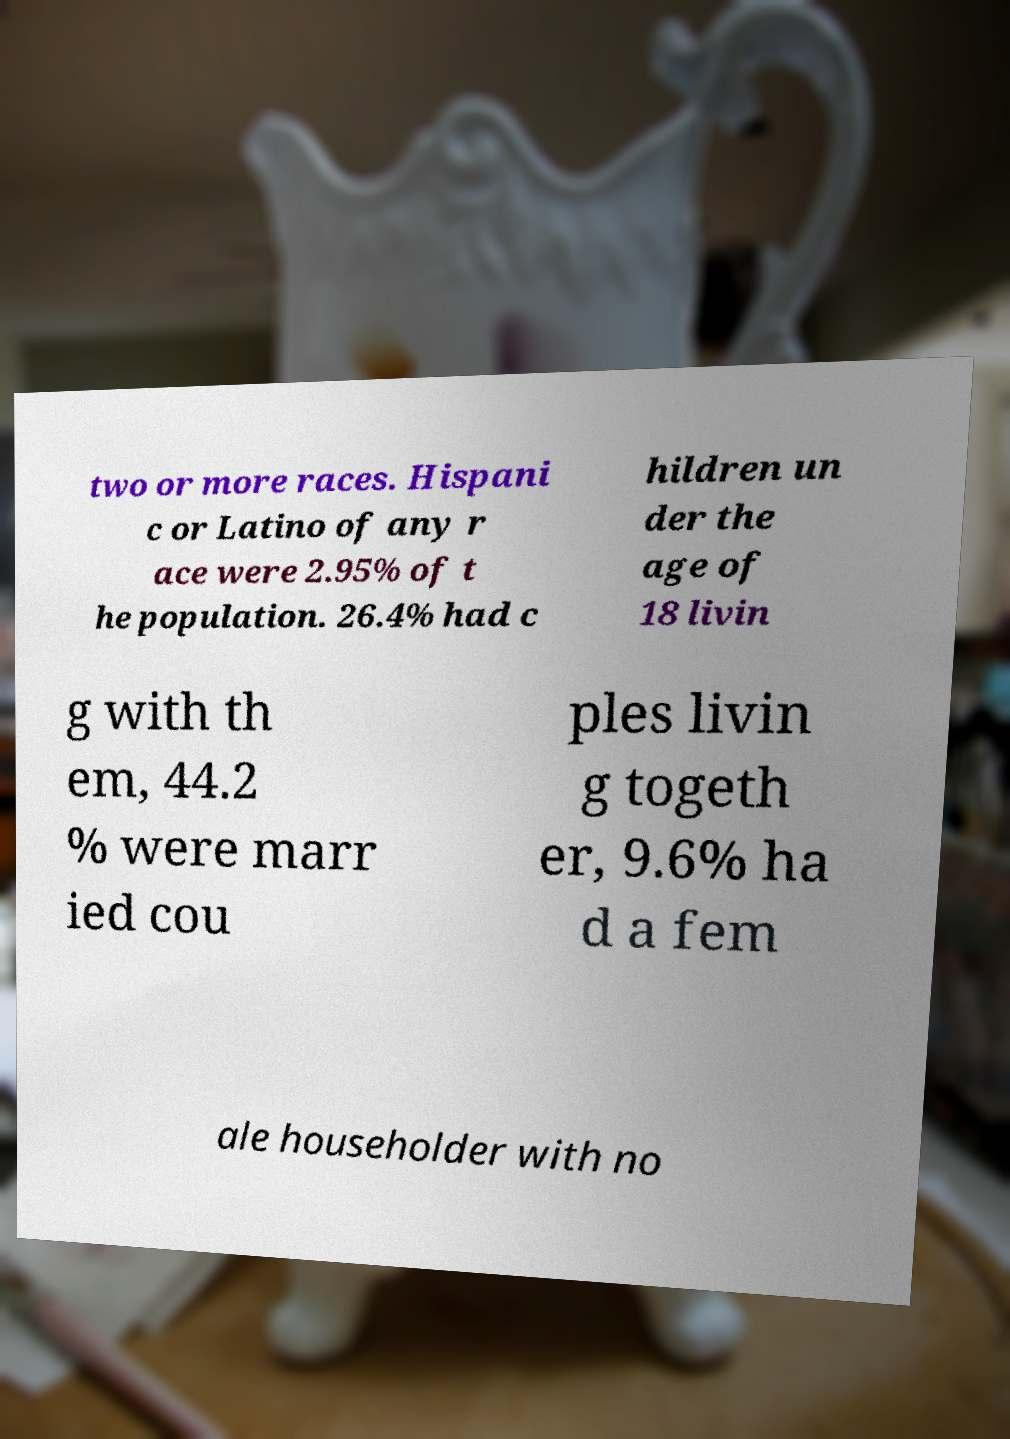Could you extract and type out the text from this image? two or more races. Hispani c or Latino of any r ace were 2.95% of t he population. 26.4% had c hildren un der the age of 18 livin g with th em, 44.2 % were marr ied cou ples livin g togeth er, 9.6% ha d a fem ale householder with no 